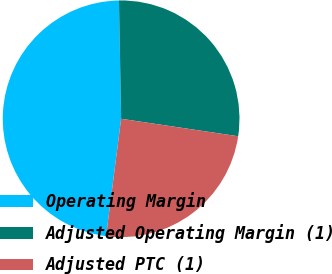<chart> <loc_0><loc_0><loc_500><loc_500><pie_chart><fcel>Operating Margin<fcel>Adjusted Operating Margin (1)<fcel>Adjusted PTC (1)<nl><fcel>47.68%<fcel>27.65%<fcel>24.67%<nl></chart> 